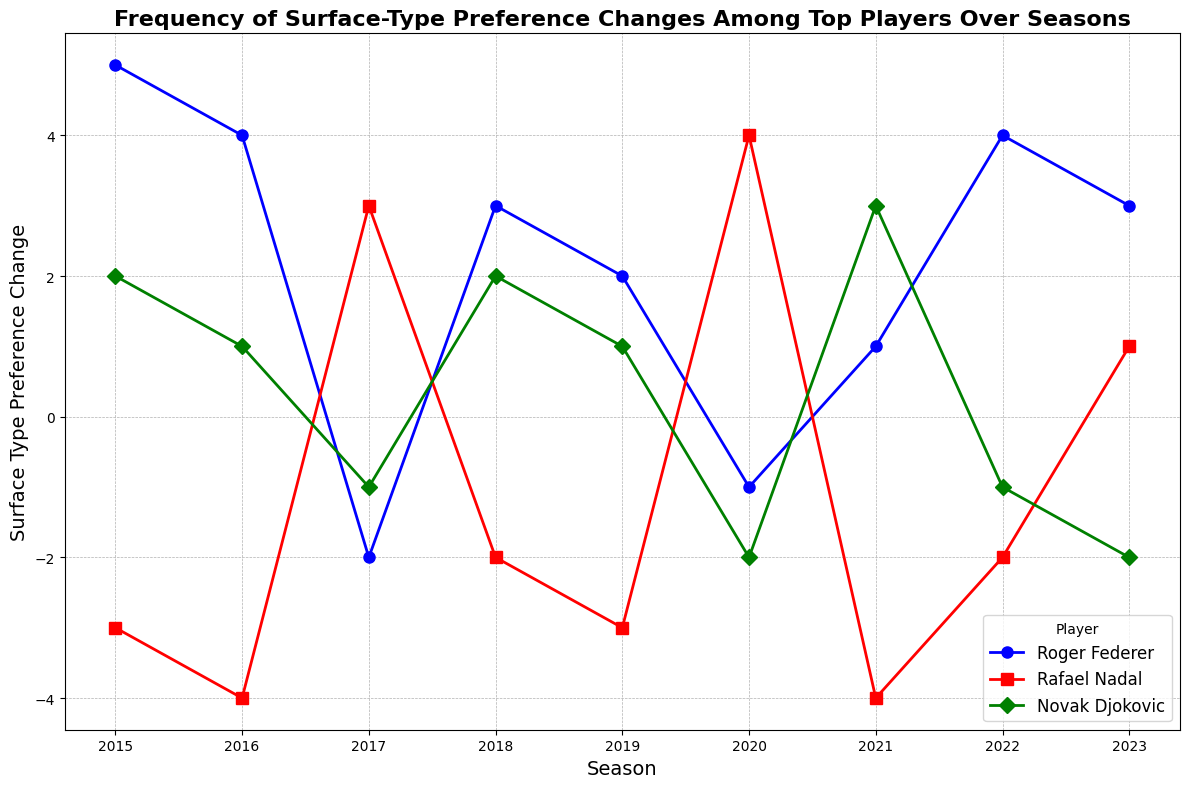Which player had the largest positive Surface Type Preference Change in any single season? Looking at the highest peak for each player, Rafael Nadal has a high value of 4 in the 2020 season.
Answer: Rafael Nadal What is the total Surface Type Preference Change for Roger Federer over the entire period? Summing the values for Roger Federer from 2015 to 2023: 5 + 4 - 2 + 3 + 2 - 1 + 1 + 4 + 3 = 19
Answer: 19 Who experienced the most significant drop in Surface Type Preference Change, and in what season? By looking at the lowest dips for each player, Rafael Nadal has a sharp decline of -4 in the 2016 and 2021 seasons.
Answer: Rafael Nadal, 2016, 2021 What was Novak Djokovic's average Surface Type Preference Change over these seasons? Summing Novak Djokovic's data (-1, 1, 3, 1, -2, -1, -2) and dividing by 9 (number of data points): (-1 + 1 + 2 + 1 - 1 + 3 -2 + -1 -2)/9 = -1/9
Answer: -0.1 Which player had the most consistent Surface Type Preference Change? Consistency can be evaluated by looking at the range (max-min). Calculate ranges: Federer (5 - (-2) = 7), Nadal (4 - (-4) = 8), Djokovic (3 - (-2) = 5). Novak Djokovic has the smallest range, hence most consistent.
Answer: Novak Djokovic In which season did Roger Federer have his maximum Surface Type Preference Change, and what was it? Checking the maximum value in Roger Federer's data, the highest is 5 in 2015.
Answer: 2015, 5 How many seasons did Rafael Nadal have a negative Surface Type Preference Change? Counting seasons where Nadal's values are negative: 2015, 2016, 2018, 2019, 2021, 2022 (total = 6)
Answer: 6 Which player had more seasons with negative Surface Type Preference Changes, Roger Federer or Novak Djokovic? Counting the seasons with negative values: Federer (2017, 2020) = 2, Djokovic (2017, 2018, 2020, 2022, 2023) = 5
Answer: Novak Djokovic Comparing Rafael Nadal and Roger Federer, who had a higher average Surface Type Preference Change from 2015 to 2023? Summing values and dividing by 9: Nadal (2015 = -3, 2016 = -4, 2017 = 3, 2018 = -2, 2019 = -3, 2020 = 4, 2021 = -4, 2022 = -2, 2023 = 1): (-3 - 4 + 3 - 2 - 3 + 4 - 4 - 2 + 1)/9 = -1.
Federer (values summed previously = 19) / 9 = 2.11
Answer: Roger Federer 